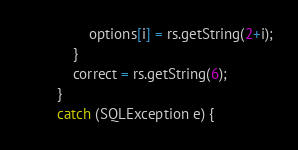Convert code to text. <code><loc_0><loc_0><loc_500><loc_500><_Java_>                options[i] = rs.getString(2+i);
            }      
            correct = rs.getString(6);
        }
        catch (SQLException e) {</code> 